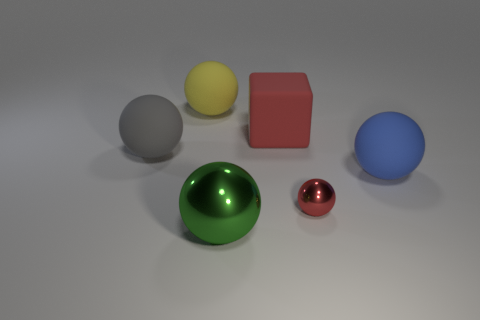Is there anything else that has the same size as the red metal ball?
Your response must be concise. No. Is the color of the shiny thing to the right of the big metal ball the same as the big shiny ball?
Your answer should be compact. No. There is a large cube that is the same color as the small ball; what is it made of?
Offer a very short reply. Rubber. Do the rubber ball that is in front of the gray matte thing and the large red thing have the same size?
Offer a very short reply. Yes. Are there any tiny balls of the same color as the tiny metal thing?
Offer a terse response. No. Is there a sphere behind the object in front of the tiny shiny ball?
Your response must be concise. Yes. Are there any tiny red things that have the same material as the yellow ball?
Keep it short and to the point. No. The large sphere that is on the right side of the big green shiny ball in front of the yellow matte thing is made of what material?
Offer a terse response. Rubber. There is a large sphere that is left of the red block and to the right of the large yellow matte object; what material is it?
Your answer should be very brief. Metal. Are there the same number of metallic balls that are behind the blue thing and small red spheres?
Your answer should be very brief. No. 